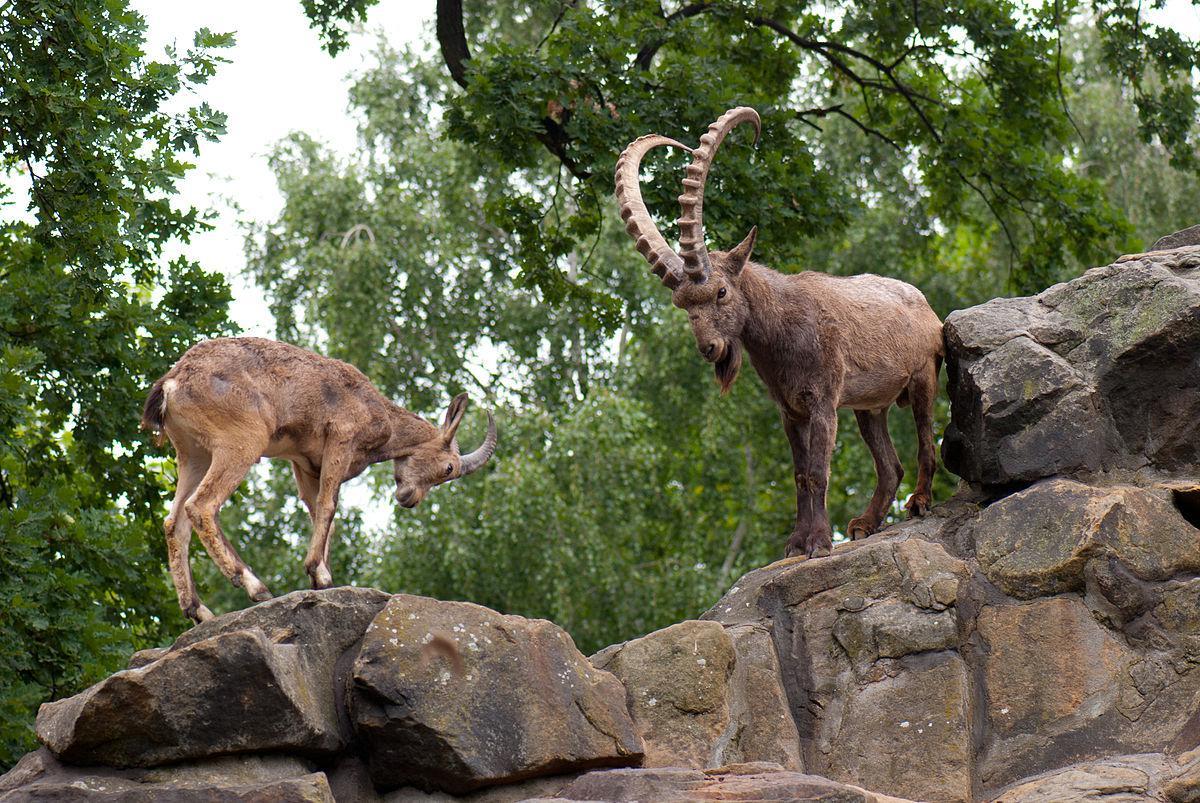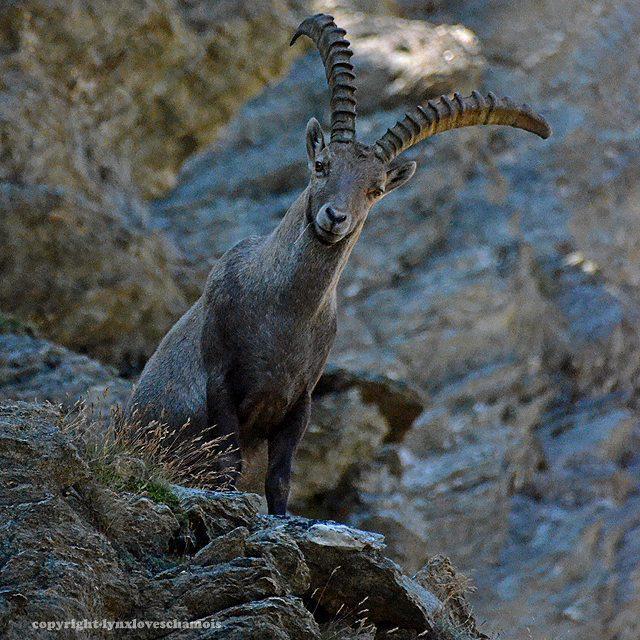The first image is the image on the left, the second image is the image on the right. Assess this claim about the two images: "An image shows one horned animal standing on dark rocks.". Correct or not? Answer yes or no. Yes. 